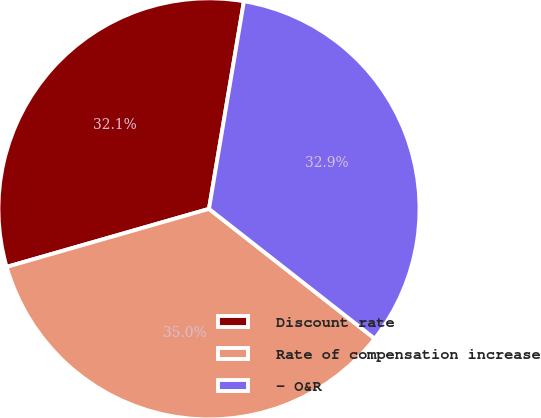Convert chart to OTSL. <chart><loc_0><loc_0><loc_500><loc_500><pie_chart><fcel>Discount rate<fcel>Rate of compensation increase<fcel>- O&R<nl><fcel>32.1%<fcel>34.98%<fcel>32.92%<nl></chart> 